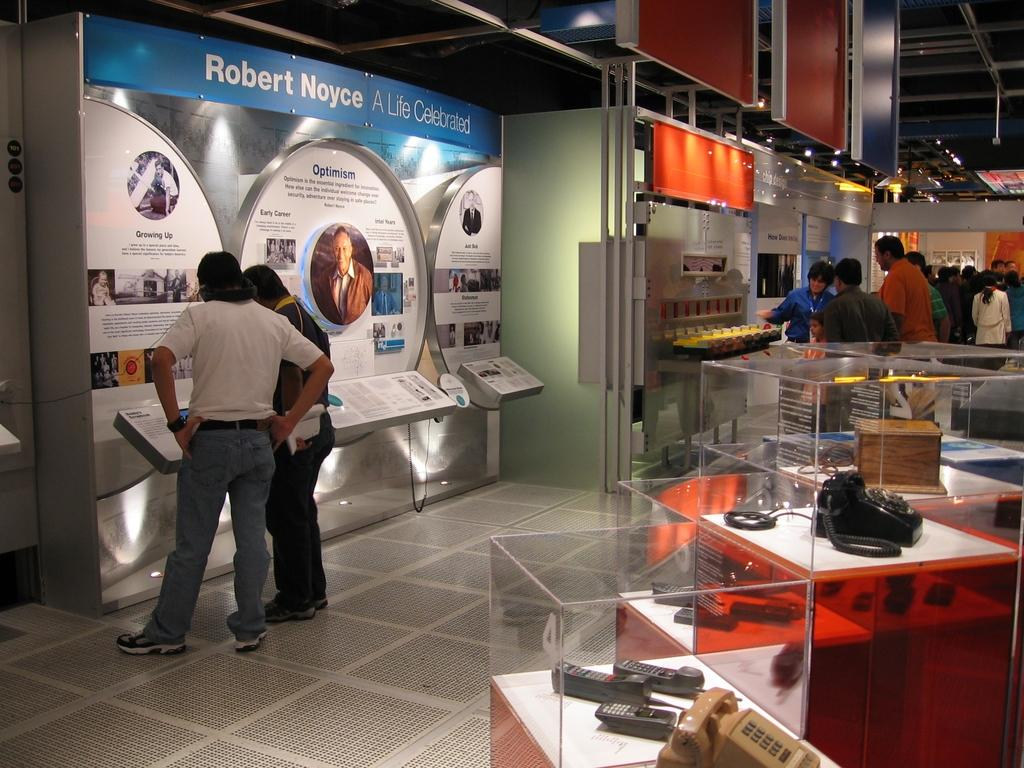What type of phones are in the image? There are landline phones in the image. How are the landline phones displayed in the image? The landline phones are in glass boxes. Can you describe the people in the image? There is a group of people standing in the image. What can be seen in the image that provides illumination? There are lights in the image. What type of signage or information is present in the image? There are boards in the image. Are there any other objects or items visible in the image? Yes, there are other items in the image. How many jellyfish are swimming in the image? There are no jellyfish present in the image. What type of nut is being cracked by the people in the image? There is no nut-cracking activity depicted in the image. 